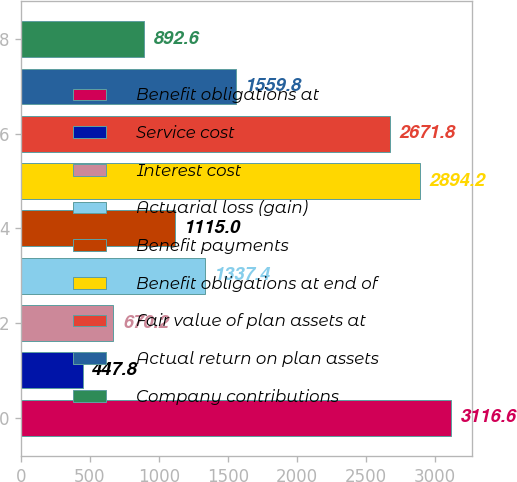Convert chart. <chart><loc_0><loc_0><loc_500><loc_500><bar_chart><fcel>Benefit obligations at<fcel>Service cost<fcel>Interest cost<fcel>Actuarial loss (gain)<fcel>Benefit payments<fcel>Benefit obligations at end of<fcel>Fair value of plan assets at<fcel>Actual return on plan assets<fcel>Company contributions<nl><fcel>3116.6<fcel>447.8<fcel>670.2<fcel>1337.4<fcel>1115<fcel>2894.2<fcel>2671.8<fcel>1559.8<fcel>892.6<nl></chart> 